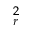Convert formula to latex. <formula><loc_0><loc_0><loc_500><loc_500>^ { 2 } _ { r }</formula> 